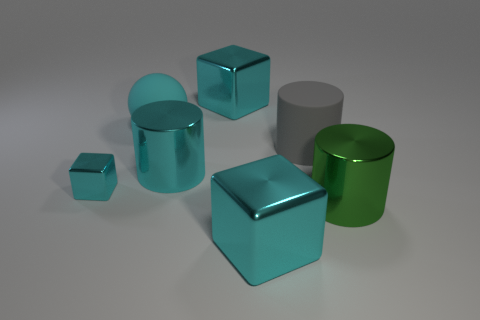Does the cyan metal object that is on the left side of the big matte ball have the same shape as the large shiny thing right of the gray rubber cylinder? No, the shapes are quite distinct. The cyan metal object on the left side of the large matte ball is cylindrical, while the large shiny object to the right of the gray rubber cylinder is cubic. Their three-dimensional geometries are different, with one having curved surfaces and circular cross-sections, and the other having flat surfaces and square cross-sections. 